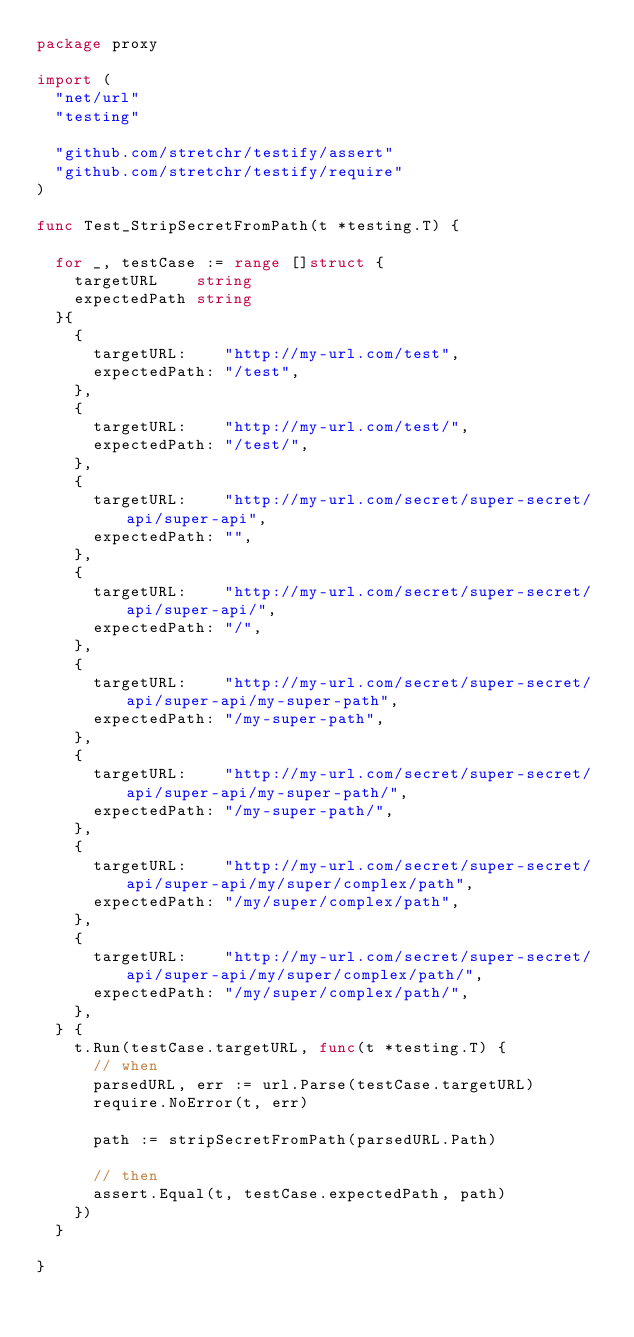<code> <loc_0><loc_0><loc_500><loc_500><_Go_>package proxy

import (
	"net/url"
	"testing"

	"github.com/stretchr/testify/assert"
	"github.com/stretchr/testify/require"
)

func Test_StripSecretFromPath(t *testing.T) {

	for _, testCase := range []struct {
		targetURL    string
		expectedPath string
	}{
		{
			targetURL:    "http://my-url.com/test",
			expectedPath: "/test",
		},
		{
			targetURL:    "http://my-url.com/test/",
			expectedPath: "/test/",
		},
		{
			targetURL:    "http://my-url.com/secret/super-secret/api/super-api",
			expectedPath: "",
		},
		{
			targetURL:    "http://my-url.com/secret/super-secret/api/super-api/",
			expectedPath: "/",
		},
		{
			targetURL:    "http://my-url.com/secret/super-secret/api/super-api/my-super-path",
			expectedPath: "/my-super-path",
		},
		{
			targetURL:    "http://my-url.com/secret/super-secret/api/super-api/my-super-path/",
			expectedPath: "/my-super-path/",
		},
		{
			targetURL:    "http://my-url.com/secret/super-secret/api/super-api/my/super/complex/path",
			expectedPath: "/my/super/complex/path",
		},
		{
			targetURL:    "http://my-url.com/secret/super-secret/api/super-api/my/super/complex/path/",
			expectedPath: "/my/super/complex/path/",
		},
	} {
		t.Run(testCase.targetURL, func(t *testing.T) {
			// when
			parsedURL, err := url.Parse(testCase.targetURL)
			require.NoError(t, err)

			path := stripSecretFromPath(parsedURL.Path)

			// then
			assert.Equal(t, testCase.expectedPath, path)
		})
	}

}
</code> 